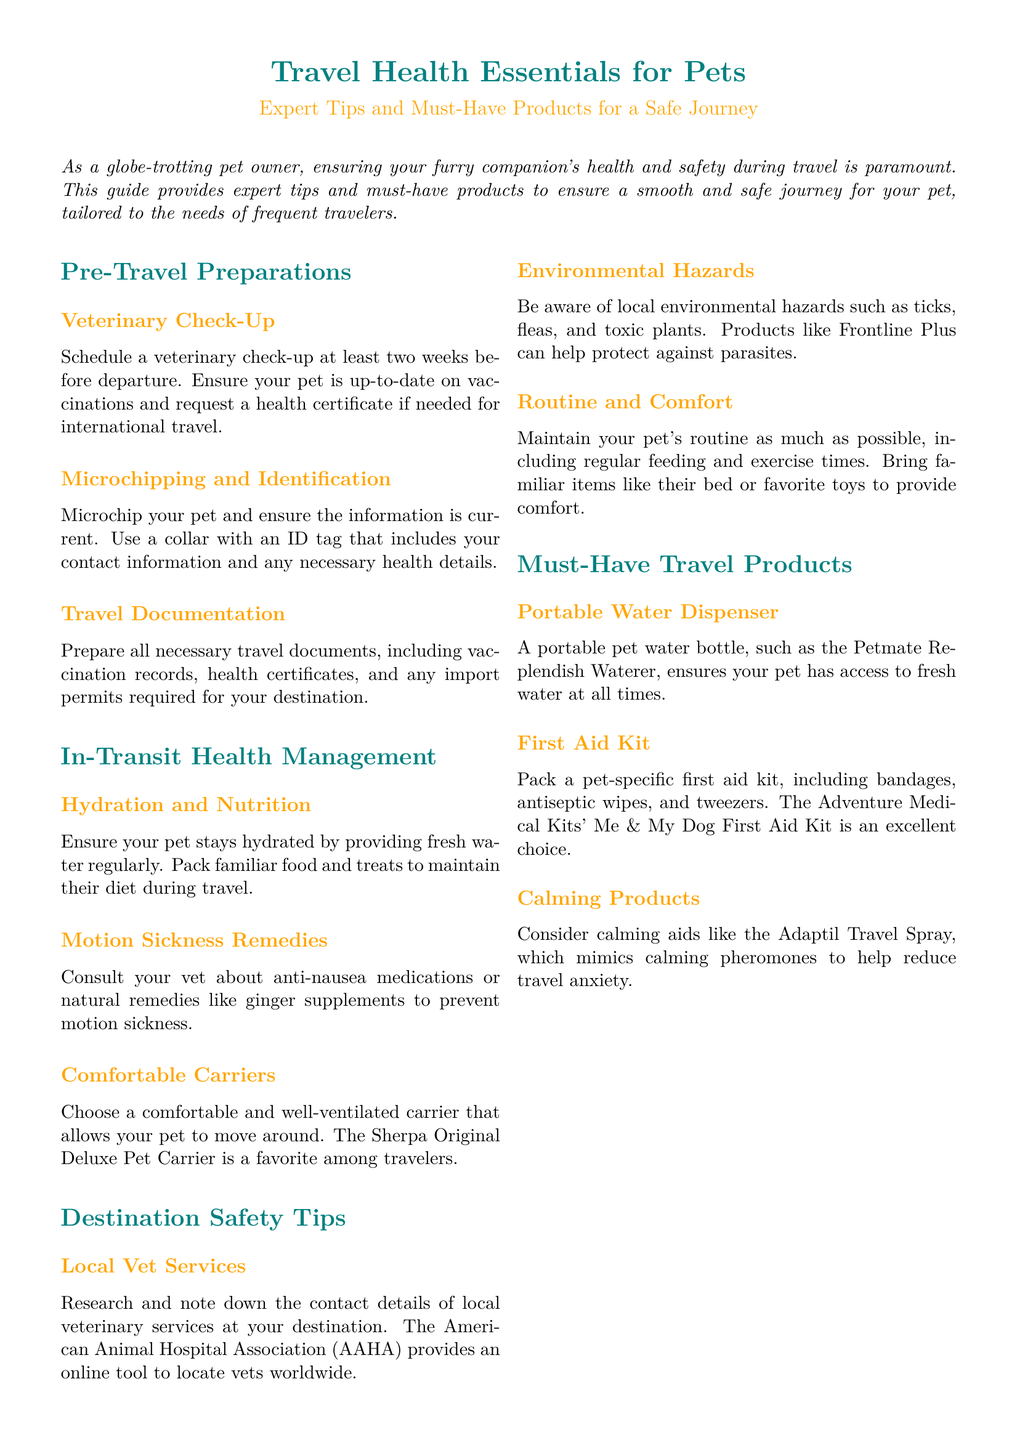What should you schedule at least two weeks before departure? The document states that you should schedule a veterinary check-up at least two weeks before departure.
Answer: veterinary check-up What portable product is recommended for hydration? The document recommends a portable pet water bottle, such as the Petmate Replendish Waterer.
Answer: Petmate Replendish Waterer Which calming product is mentioned to reduce travel anxiety? The document mentions the Adaptil Travel Spray as a calming aid that mimics calming pheromones.
Answer: Adaptil Travel Spray What service should you research and note down at your destination? The document advises researching and noting down contact details of local veterinary services at your destination.
Answer: local veterinary services What is a must-have item to pack for emergencies? The document specifies packing a pet-specific first aid kit, including bandages and antiseptic wipes.
Answer: first aid kit Which certification may be needed for international travel? The document mentions needing a health certificate for international travel.
Answer: health certificate What environmental hazards should you be aware of? The document mentions being aware of ticks, fleas, and toxic plants as local environmental hazards.
Answer: ticks, fleas, and toxic plants How can you maintain your pet's routine during travel? The document suggests maintaining regular feeding and exercise times to keep your pet's routine.
Answer: regular feeding and exercise times 